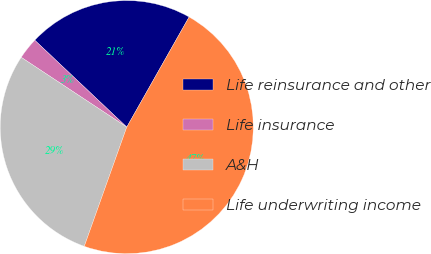Convert chart to OTSL. <chart><loc_0><loc_0><loc_500><loc_500><pie_chart><fcel>Life reinsurance and other<fcel>Life insurance<fcel>A&H<fcel>Life underwriting income<nl><fcel>21.15%<fcel>2.75%<fcel>28.85%<fcel>47.25%<nl></chart> 